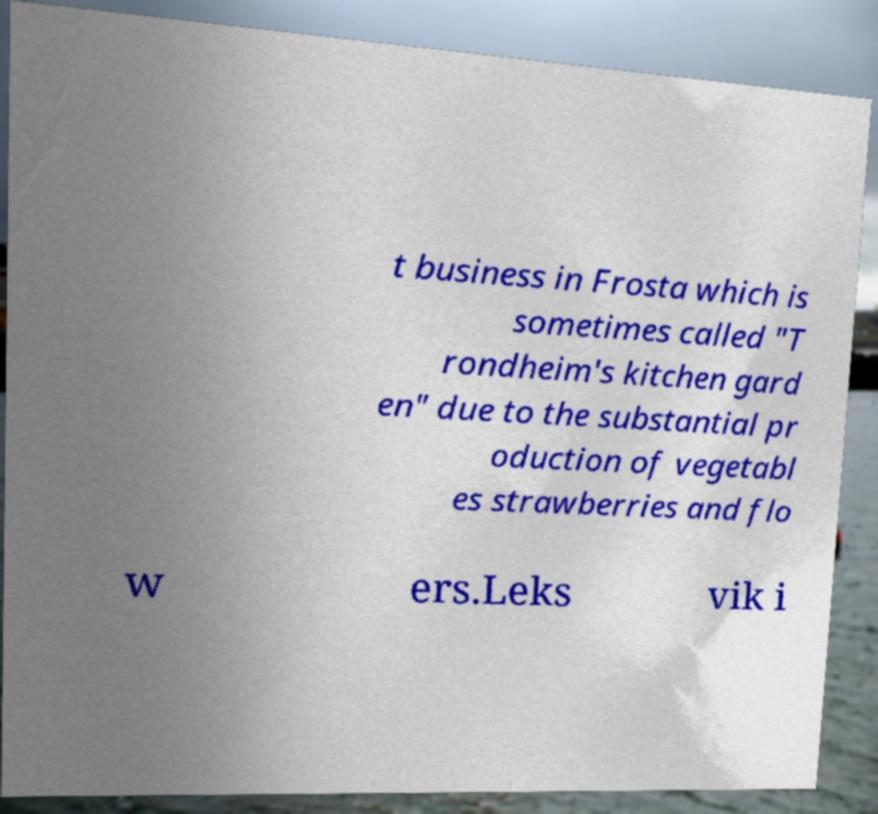For documentation purposes, I need the text within this image transcribed. Could you provide that? t business in Frosta which is sometimes called "T rondheim's kitchen gard en" due to the substantial pr oduction of vegetabl es strawberries and flo w ers.Leks vik i 